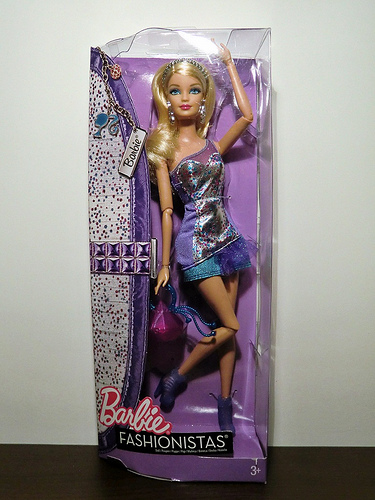<image>
Is there a doll behind the box? No. The doll is not behind the box. From this viewpoint, the doll appears to be positioned elsewhere in the scene. Is the doll in front of the package? No. The doll is not in front of the package. The spatial positioning shows a different relationship between these objects. 